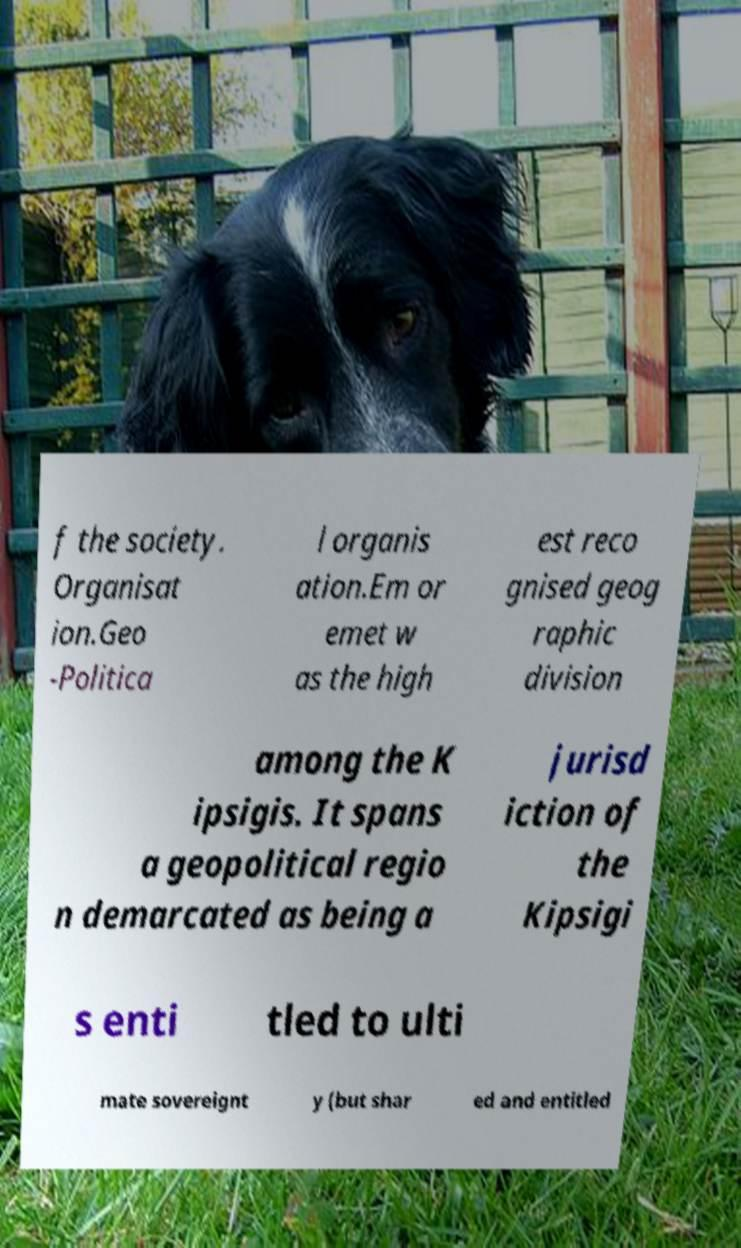Please identify and transcribe the text found in this image. f the society. Organisat ion.Geo -Politica l organis ation.Em or emet w as the high est reco gnised geog raphic division among the K ipsigis. It spans a geopolitical regio n demarcated as being a jurisd iction of the Kipsigi s enti tled to ulti mate sovereignt y (but shar ed and entitled 